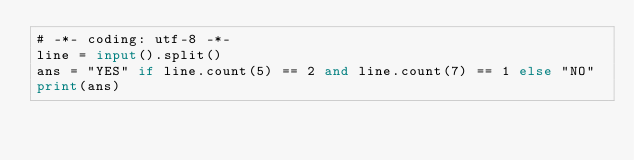Convert code to text. <code><loc_0><loc_0><loc_500><loc_500><_Python_># -*- coding: utf-8 -*-
line = input().split()
ans = "YES" if line.count(5) == 2 and line.count(7) == 1 else "NO"
print(ans)
</code> 